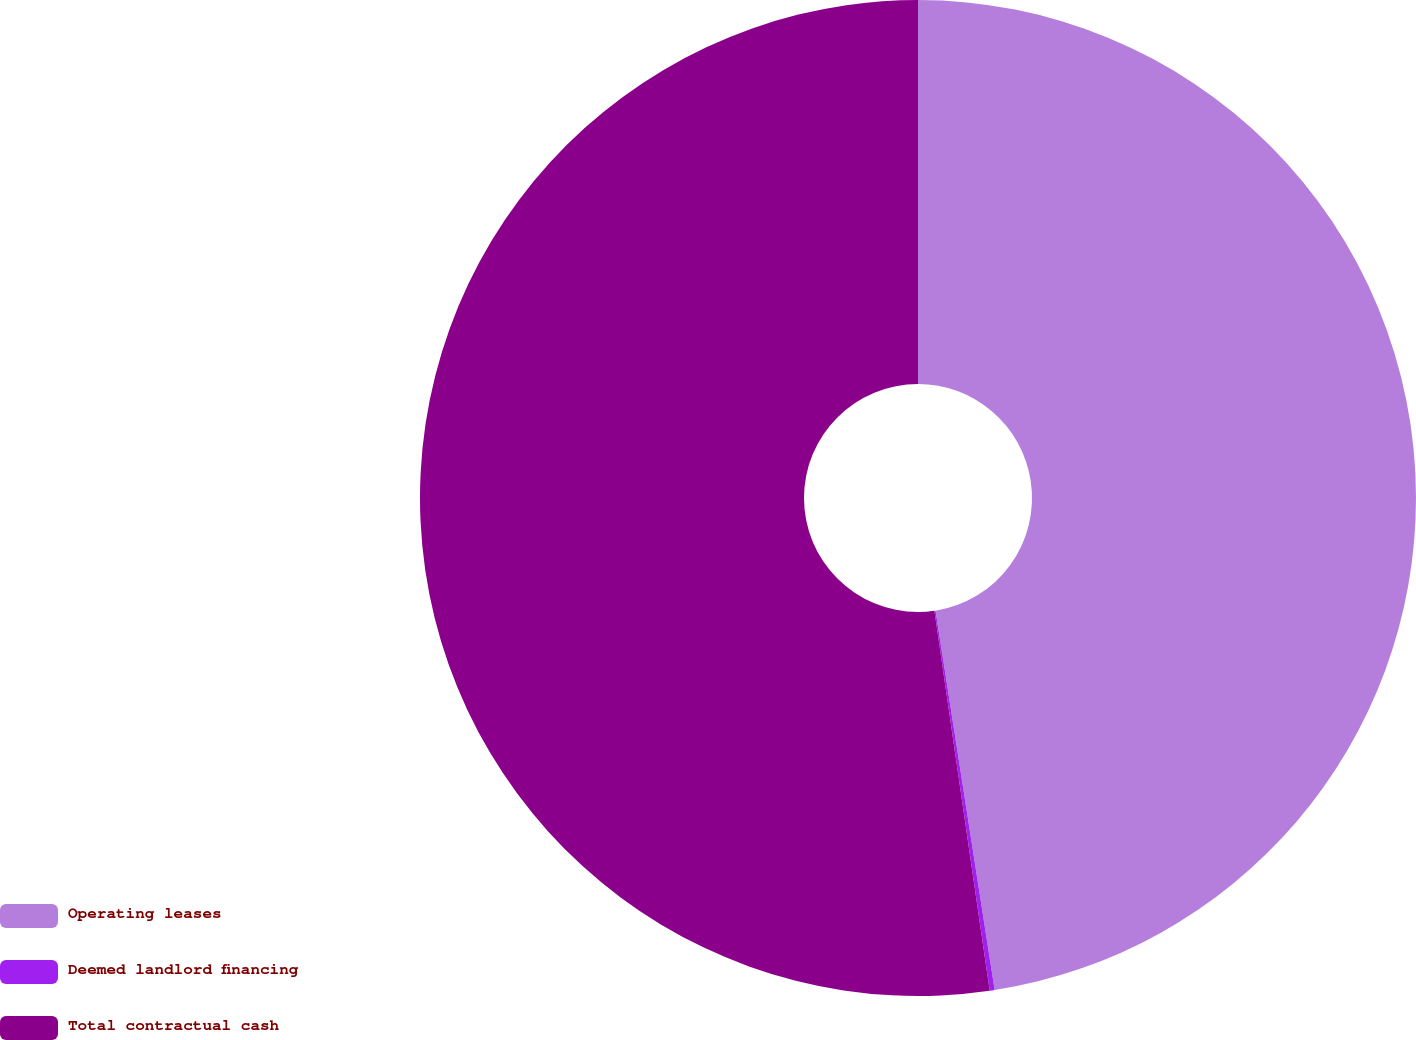Convert chart to OTSL. <chart><loc_0><loc_0><loc_500><loc_500><pie_chart><fcel>Operating leases<fcel>Deemed landlord financing<fcel>Total contractual cash<nl><fcel>47.54%<fcel>0.16%<fcel>52.3%<nl></chart> 